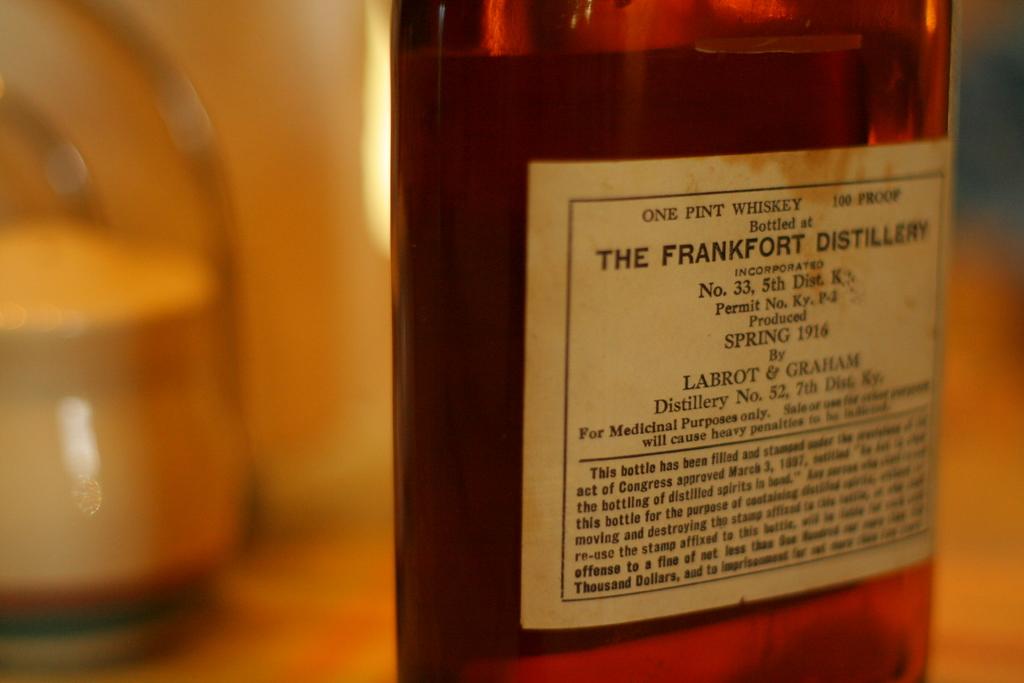Where was this whiskey bottled?
Your answer should be very brief. The frankfort distillery. 